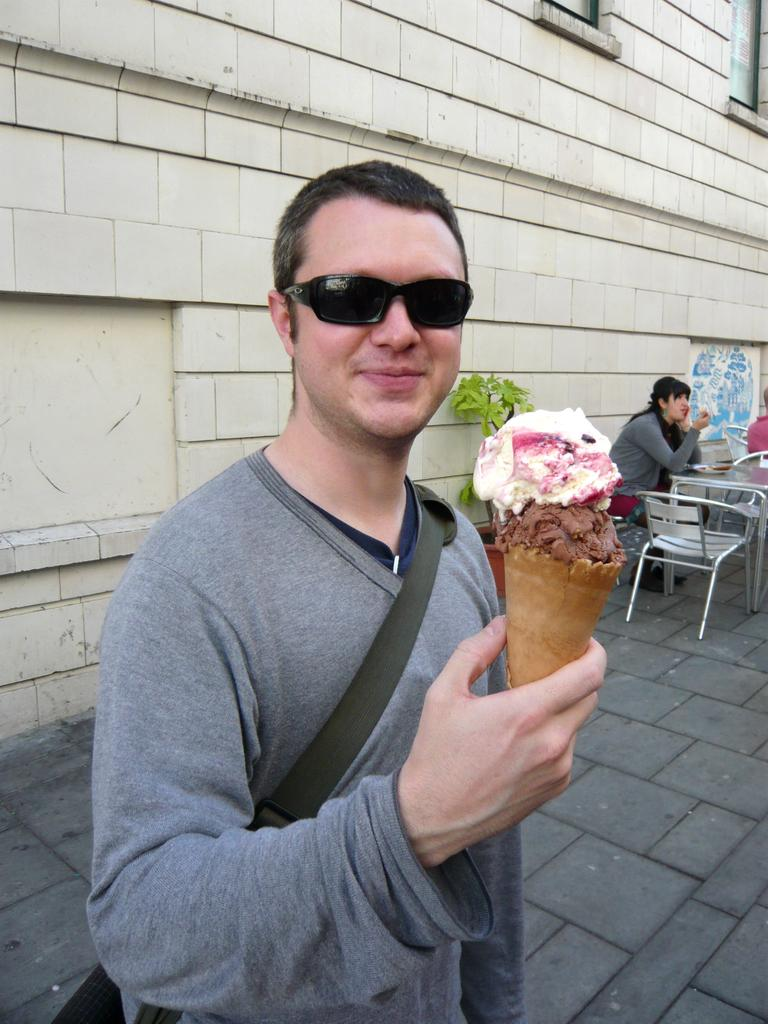What is the main subject of the image? There is a guy in the image. What is the guy wearing? The guy is wearing spectacles. What is the guy holding in the image? The guy is holding an ice cream. What can be seen in the background of the image? There is a wall and tables in the background of the image. What are the people in the background doing? The people in the background are sitting on the tables. What type of branch can be seen growing from the guy's head in the image? There is no branch growing from the guy's head in the image; he is simply wearing spectacles and holding an ice cream. 